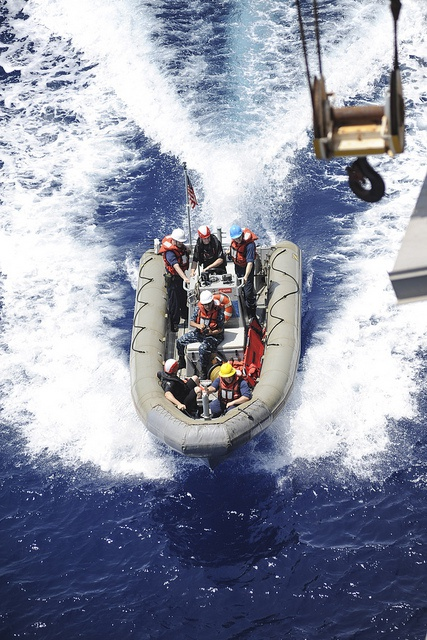Describe the objects in this image and their specific colors. I can see boat in darkgray, lightgray, and gray tones, people in darkgray, black, gray, white, and maroon tones, people in darkgray, black, white, gray, and maroon tones, people in darkgray, black, gray, maroon, and white tones, and people in darkgray, black, gray, and maroon tones in this image. 